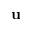<formula> <loc_0><loc_0><loc_500><loc_500>{ \mathbf u }</formula> 